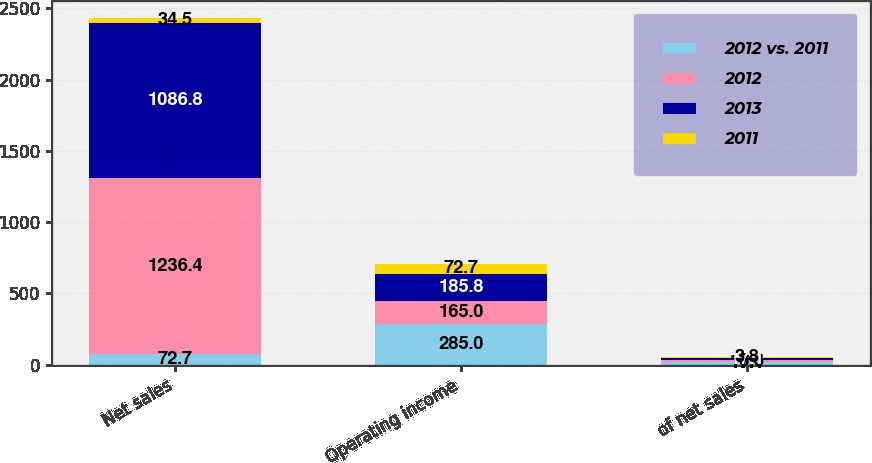Convert chart. <chart><loc_0><loc_0><loc_500><loc_500><stacked_bar_chart><ecel><fcel>Net sales<fcel>Operating income<fcel>of net sales<nl><fcel>2012 vs. 2011<fcel>72.7<fcel>285<fcel>17.1<nl><fcel>2012<fcel>1236.4<fcel>165<fcel>13.3<nl><fcel>2013<fcel>1086.8<fcel>185.8<fcel>17.1<nl><fcel>2011<fcel>34.5<fcel>72.7<fcel>3.8<nl></chart> 